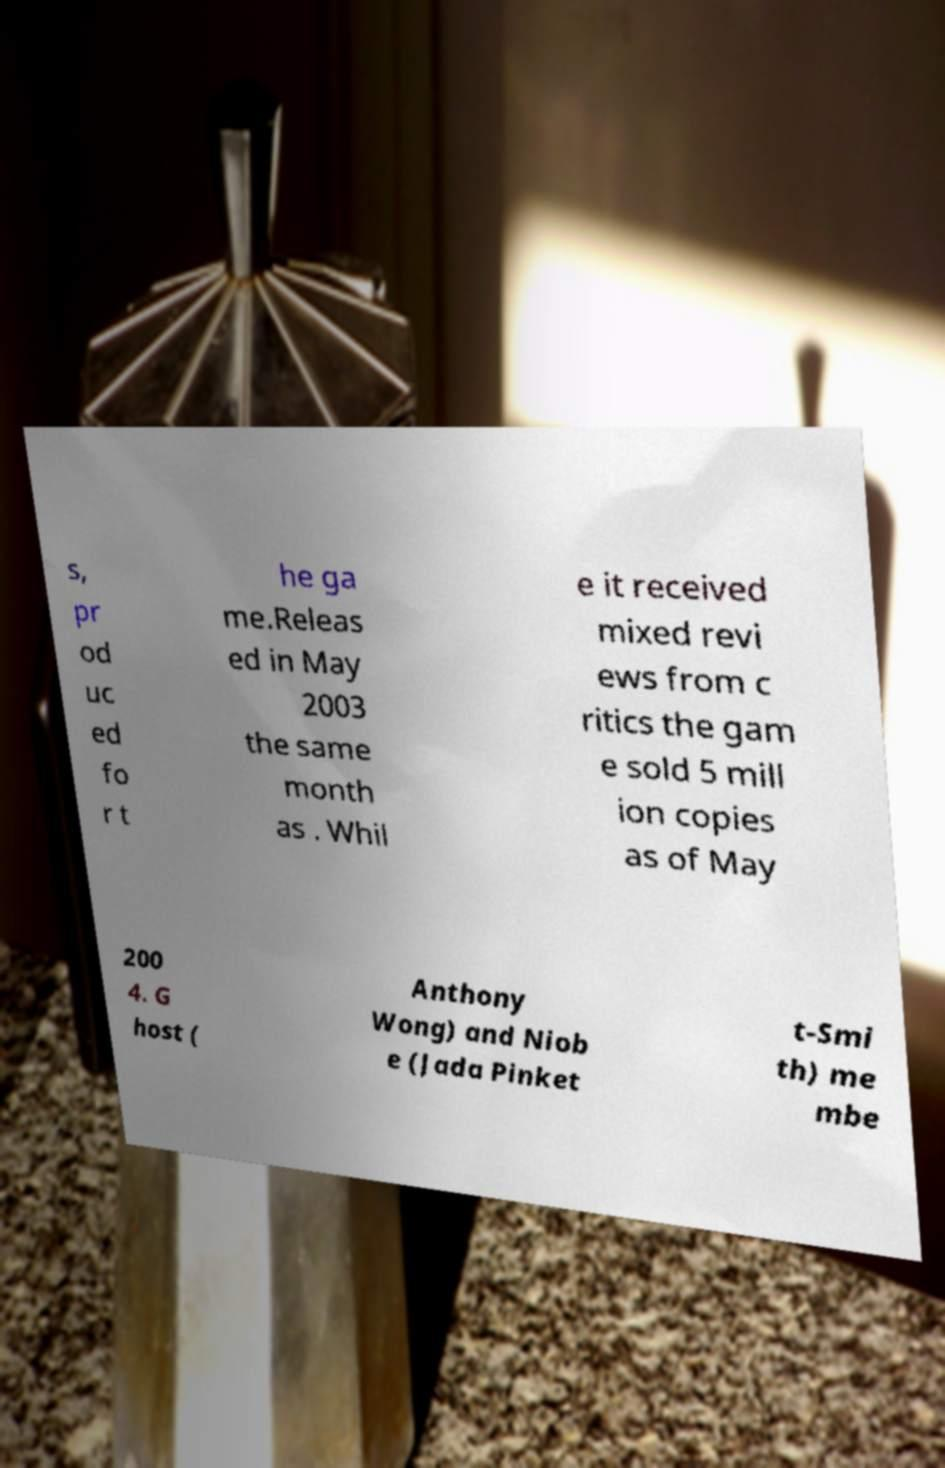Could you extract and type out the text from this image? s, pr od uc ed fo r t he ga me.Releas ed in May 2003 the same month as . Whil e it received mixed revi ews from c ritics the gam e sold 5 mill ion copies as of May 200 4. G host ( Anthony Wong) and Niob e (Jada Pinket t-Smi th) me mbe 